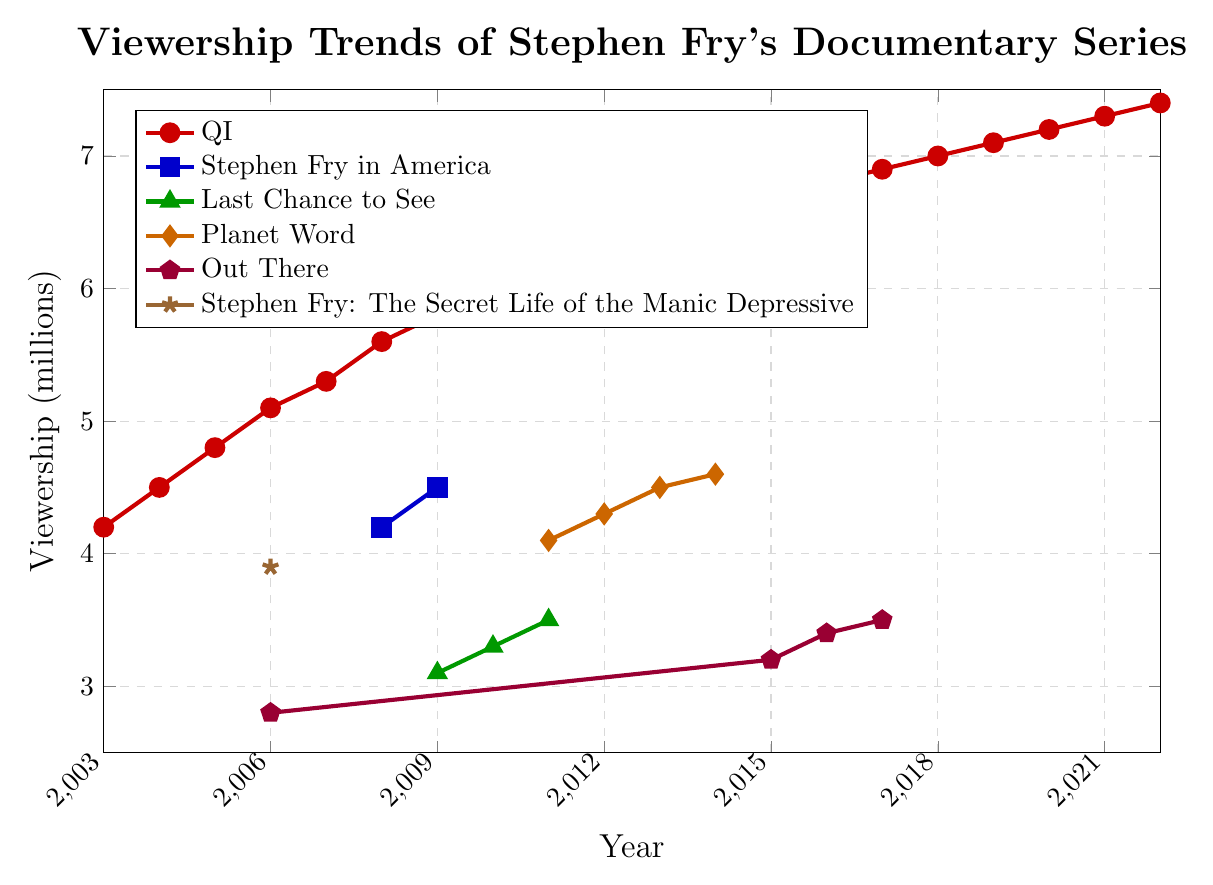What was the viewership for "QI" in 2006 and how did it change by 2016? First, find the viewership of "QI" in 2006, which is 5.1 million. Then, look at the viewership in 2016, which is 6.8 million. Subtract the 2006 viewership from 2016 viewership: 6.8 - 5.1 = 1.7 million.
Answer: 1.7 million Which series had the highest viewership in 2009? Compare the viewership numbers of all series in 2009. "QI" had 5.8 million, "Stephen Fry in America" had 4.5 million, and "Last Chance to See" had 3.1 million. "QI" had the highest viewership.
Answer: QI Between "Planet Word" and "Out There", which series had a higher viewership in 2015? Look at the viewership numbers for both series in 2015. "Planet Word" does not have data for 2015, while "Out There" had 3.2 million. Hence "Out There" must be the default.
Answer: Out There What is the average viewership of "Stephen Fry: The Secret Life of the Manic Depressive" over the years provided? The viewership numbers available are 3.9 million in 2006. Since it only has one data point, the average is 3.9 million.
Answer: 3.9 million How does the viewership trend of "QI" compare to "Stephen Fry in America" from their first available year to their last? For "QI", we see a continuous increase from 4.2 million in 2003 to 7.4 million in 2022. "Stephen Fry in America" starts at 4.2 million in 2008 and slightly increases to 4.5 million in 2009, showing a much shorter span without significant growth.
Answer: QI had a more consistent and larger increase In which year did "Last Chance to See" and "Planet Word" both have viewership data? Cross-reference the years of viewership for both series. "Last Chance to See" has data from 2009 to 2011 and "Planet Word" from 2011 to 2014. They both have data in 2011.
Answer: 2011 During which year did "QI" reach 6 million viewership? Track the growth of "QI" through the years: in 2010, it hits 6.0 million for the first time.
Answer: 2010 Which series had viewership data only present once in the plot? Identify the series with only one data point: "Stephen Fry: The Secret Life of the Manic Depressive" has data only in 2006.
Answer: Stephen Fry: The Secret Life of the Manic Depressive 